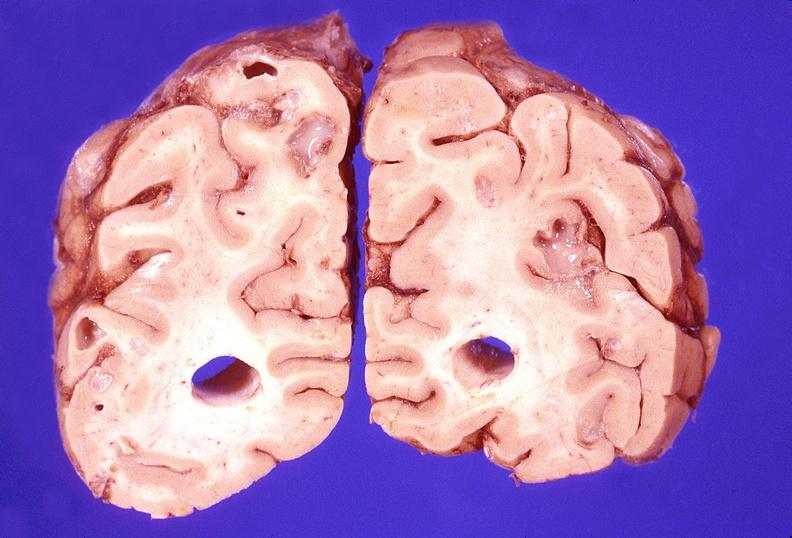does this image show brain abscess?
Answer the question using a single word or phrase. Yes 